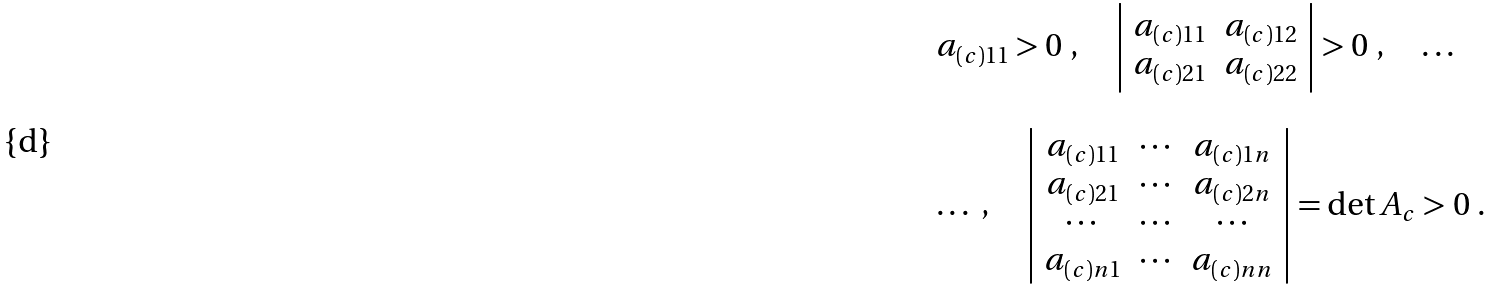Convert formula to latex. <formula><loc_0><loc_0><loc_500><loc_500>\begin{array} { l } a _ { ( c ) 1 1 } > 0 \ , \quad \left | \begin{array} { c c } a _ { ( c ) 1 1 } & a _ { ( c ) 1 2 } \\ a _ { ( c ) 2 1 } & a _ { ( c ) 2 2 } \end{array} \right | > 0 \ , \quad \dots \\ \\ \dots \ , \quad \left | \begin{array} { c c c } a _ { ( c ) 1 1 } & \cdots & a _ { ( c ) 1 n } \\ a _ { ( c ) 2 1 } & \cdots & a _ { ( c ) 2 n } \\ \cdots & \cdots & \cdots \\ a _ { ( c ) n 1 } & \cdots & a _ { ( c ) n n } \end{array} \right | = \det A _ { c } > 0 \ . \end{array}</formula> 